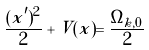<formula> <loc_0><loc_0><loc_500><loc_500>\frac { ( x ^ { \prime } ) ^ { 2 } } { 2 } + V ( x ) = \frac { \Omega _ { k , 0 } } { 2 }</formula> 